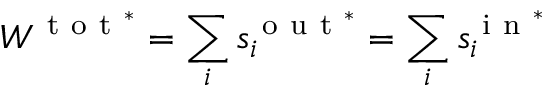<formula> <loc_0><loc_0><loc_500><loc_500>W ^ { t o t ^ { * } } = \sum _ { i } s _ { i } ^ { o u t ^ { * } } = \sum _ { i } s _ { i } ^ { i n ^ { * } }</formula> 